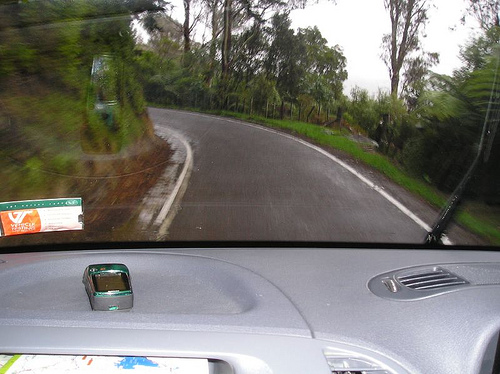<image>
Is the windshield in front of the tree? Yes. The windshield is positioned in front of the tree, appearing closer to the camera viewpoint. 